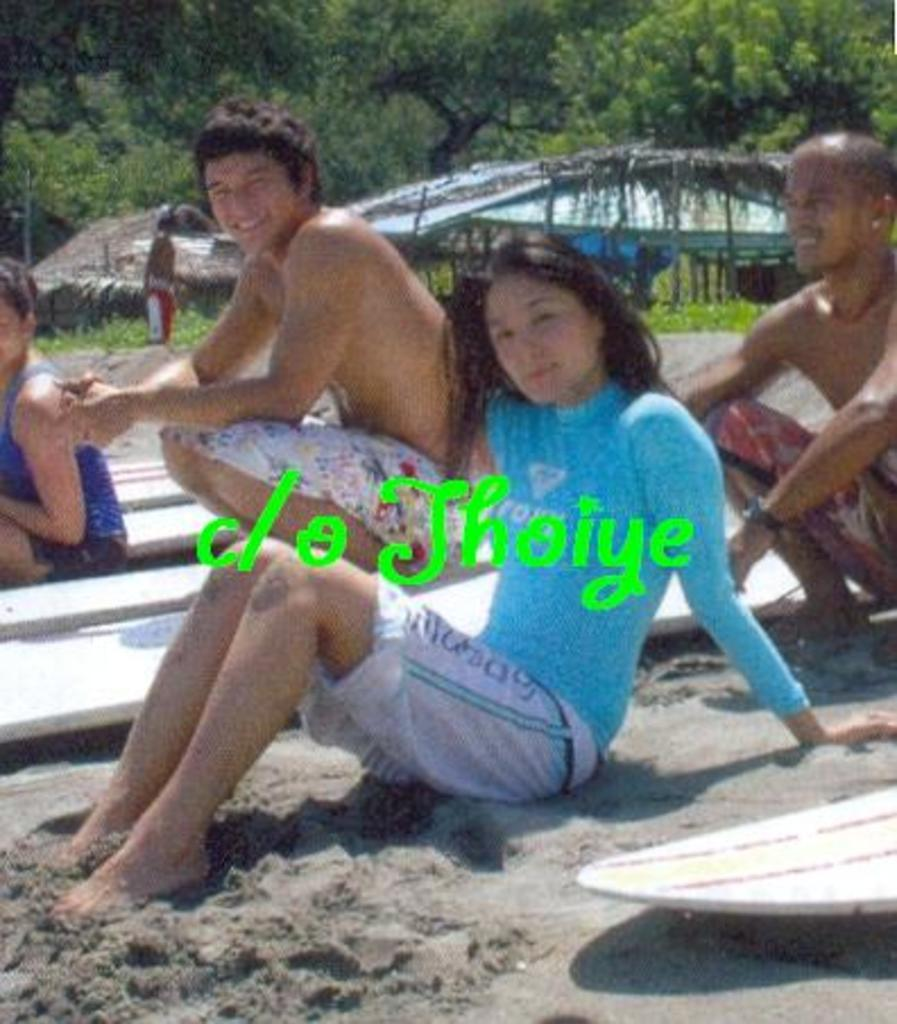Who or what can be seen in the image? There are people in the image. What objects are associated with the people in the image? Surfboards are visible in the image. What type of terrain is present in the image? Sand is present in the image. Is there any text or writing in the image? Yes, there is text in the image. What structures can be seen in the background of the image? There are sheds in the background of the image. What type of vegetation is visible in the background of the image? Plants and trees are visible in the background of the image. Can you see any deer or carriages in the image? No, there are no deer or carriages present in the image. Is there an airplane visible in the image? No, there is no airplane visible in the image. 